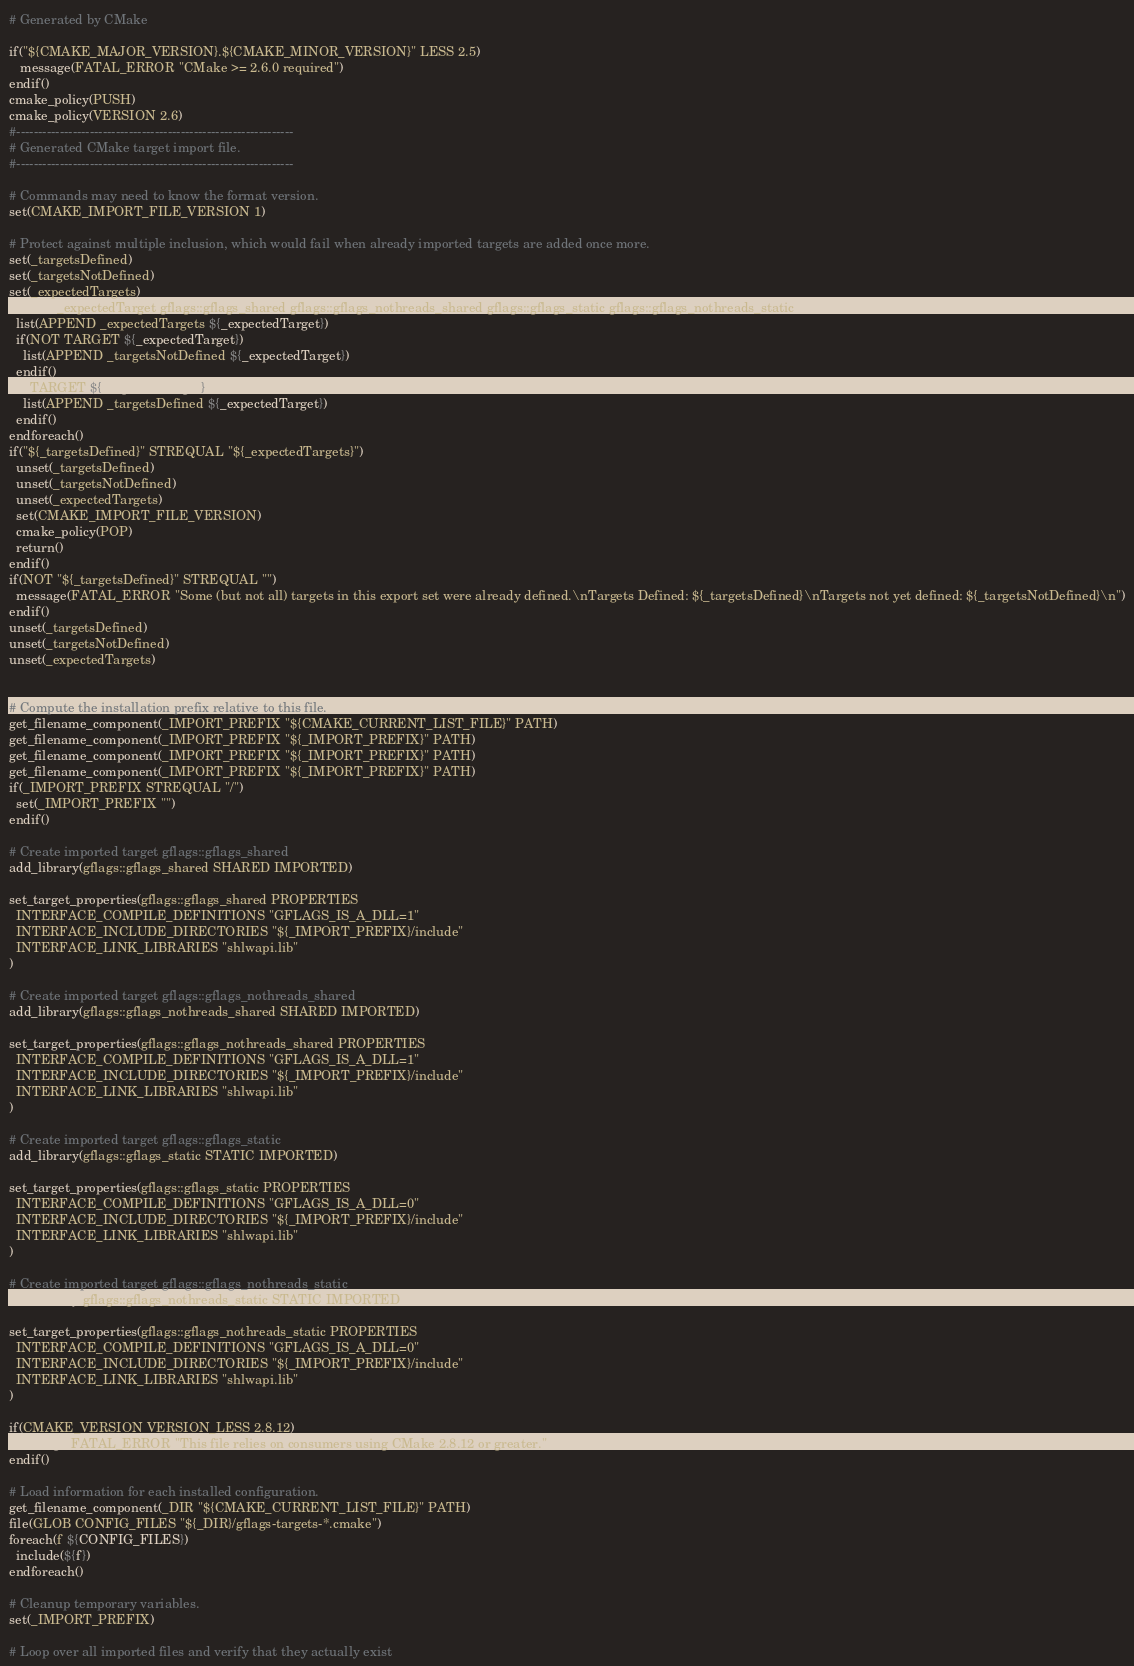<code> <loc_0><loc_0><loc_500><loc_500><_CMake_># Generated by CMake

if("${CMAKE_MAJOR_VERSION}.${CMAKE_MINOR_VERSION}" LESS 2.5)
   message(FATAL_ERROR "CMake >= 2.6.0 required")
endif()
cmake_policy(PUSH)
cmake_policy(VERSION 2.6)
#----------------------------------------------------------------
# Generated CMake target import file.
#----------------------------------------------------------------

# Commands may need to know the format version.
set(CMAKE_IMPORT_FILE_VERSION 1)

# Protect against multiple inclusion, which would fail when already imported targets are added once more.
set(_targetsDefined)
set(_targetsNotDefined)
set(_expectedTargets)
foreach(_expectedTarget gflags::gflags_shared gflags::gflags_nothreads_shared gflags::gflags_static gflags::gflags_nothreads_static)
  list(APPEND _expectedTargets ${_expectedTarget})
  if(NOT TARGET ${_expectedTarget})
    list(APPEND _targetsNotDefined ${_expectedTarget})
  endif()
  if(TARGET ${_expectedTarget})
    list(APPEND _targetsDefined ${_expectedTarget})
  endif()
endforeach()
if("${_targetsDefined}" STREQUAL "${_expectedTargets}")
  unset(_targetsDefined)
  unset(_targetsNotDefined)
  unset(_expectedTargets)
  set(CMAKE_IMPORT_FILE_VERSION)
  cmake_policy(POP)
  return()
endif()
if(NOT "${_targetsDefined}" STREQUAL "")
  message(FATAL_ERROR "Some (but not all) targets in this export set were already defined.\nTargets Defined: ${_targetsDefined}\nTargets not yet defined: ${_targetsNotDefined}\n")
endif()
unset(_targetsDefined)
unset(_targetsNotDefined)
unset(_expectedTargets)


# Compute the installation prefix relative to this file.
get_filename_component(_IMPORT_PREFIX "${CMAKE_CURRENT_LIST_FILE}" PATH)
get_filename_component(_IMPORT_PREFIX "${_IMPORT_PREFIX}" PATH)
get_filename_component(_IMPORT_PREFIX "${_IMPORT_PREFIX}" PATH)
get_filename_component(_IMPORT_PREFIX "${_IMPORT_PREFIX}" PATH)
if(_IMPORT_PREFIX STREQUAL "/")
  set(_IMPORT_PREFIX "")
endif()

# Create imported target gflags::gflags_shared
add_library(gflags::gflags_shared SHARED IMPORTED)

set_target_properties(gflags::gflags_shared PROPERTIES
  INTERFACE_COMPILE_DEFINITIONS "GFLAGS_IS_A_DLL=1"
  INTERFACE_INCLUDE_DIRECTORIES "${_IMPORT_PREFIX}/include"
  INTERFACE_LINK_LIBRARIES "shlwapi.lib"
)

# Create imported target gflags::gflags_nothreads_shared
add_library(gflags::gflags_nothreads_shared SHARED IMPORTED)

set_target_properties(gflags::gflags_nothreads_shared PROPERTIES
  INTERFACE_COMPILE_DEFINITIONS "GFLAGS_IS_A_DLL=1"
  INTERFACE_INCLUDE_DIRECTORIES "${_IMPORT_PREFIX}/include"
  INTERFACE_LINK_LIBRARIES "shlwapi.lib"
)

# Create imported target gflags::gflags_static
add_library(gflags::gflags_static STATIC IMPORTED)

set_target_properties(gflags::gflags_static PROPERTIES
  INTERFACE_COMPILE_DEFINITIONS "GFLAGS_IS_A_DLL=0"
  INTERFACE_INCLUDE_DIRECTORIES "${_IMPORT_PREFIX}/include"
  INTERFACE_LINK_LIBRARIES "shlwapi.lib"
)

# Create imported target gflags::gflags_nothreads_static
add_library(gflags::gflags_nothreads_static STATIC IMPORTED)

set_target_properties(gflags::gflags_nothreads_static PROPERTIES
  INTERFACE_COMPILE_DEFINITIONS "GFLAGS_IS_A_DLL=0"
  INTERFACE_INCLUDE_DIRECTORIES "${_IMPORT_PREFIX}/include"
  INTERFACE_LINK_LIBRARIES "shlwapi.lib"
)

if(CMAKE_VERSION VERSION_LESS 2.8.12)
  message(FATAL_ERROR "This file relies on consumers using CMake 2.8.12 or greater.")
endif()

# Load information for each installed configuration.
get_filename_component(_DIR "${CMAKE_CURRENT_LIST_FILE}" PATH)
file(GLOB CONFIG_FILES "${_DIR}/gflags-targets-*.cmake")
foreach(f ${CONFIG_FILES})
  include(${f})
endforeach()

# Cleanup temporary variables.
set(_IMPORT_PREFIX)

# Loop over all imported files and verify that they actually exist</code> 